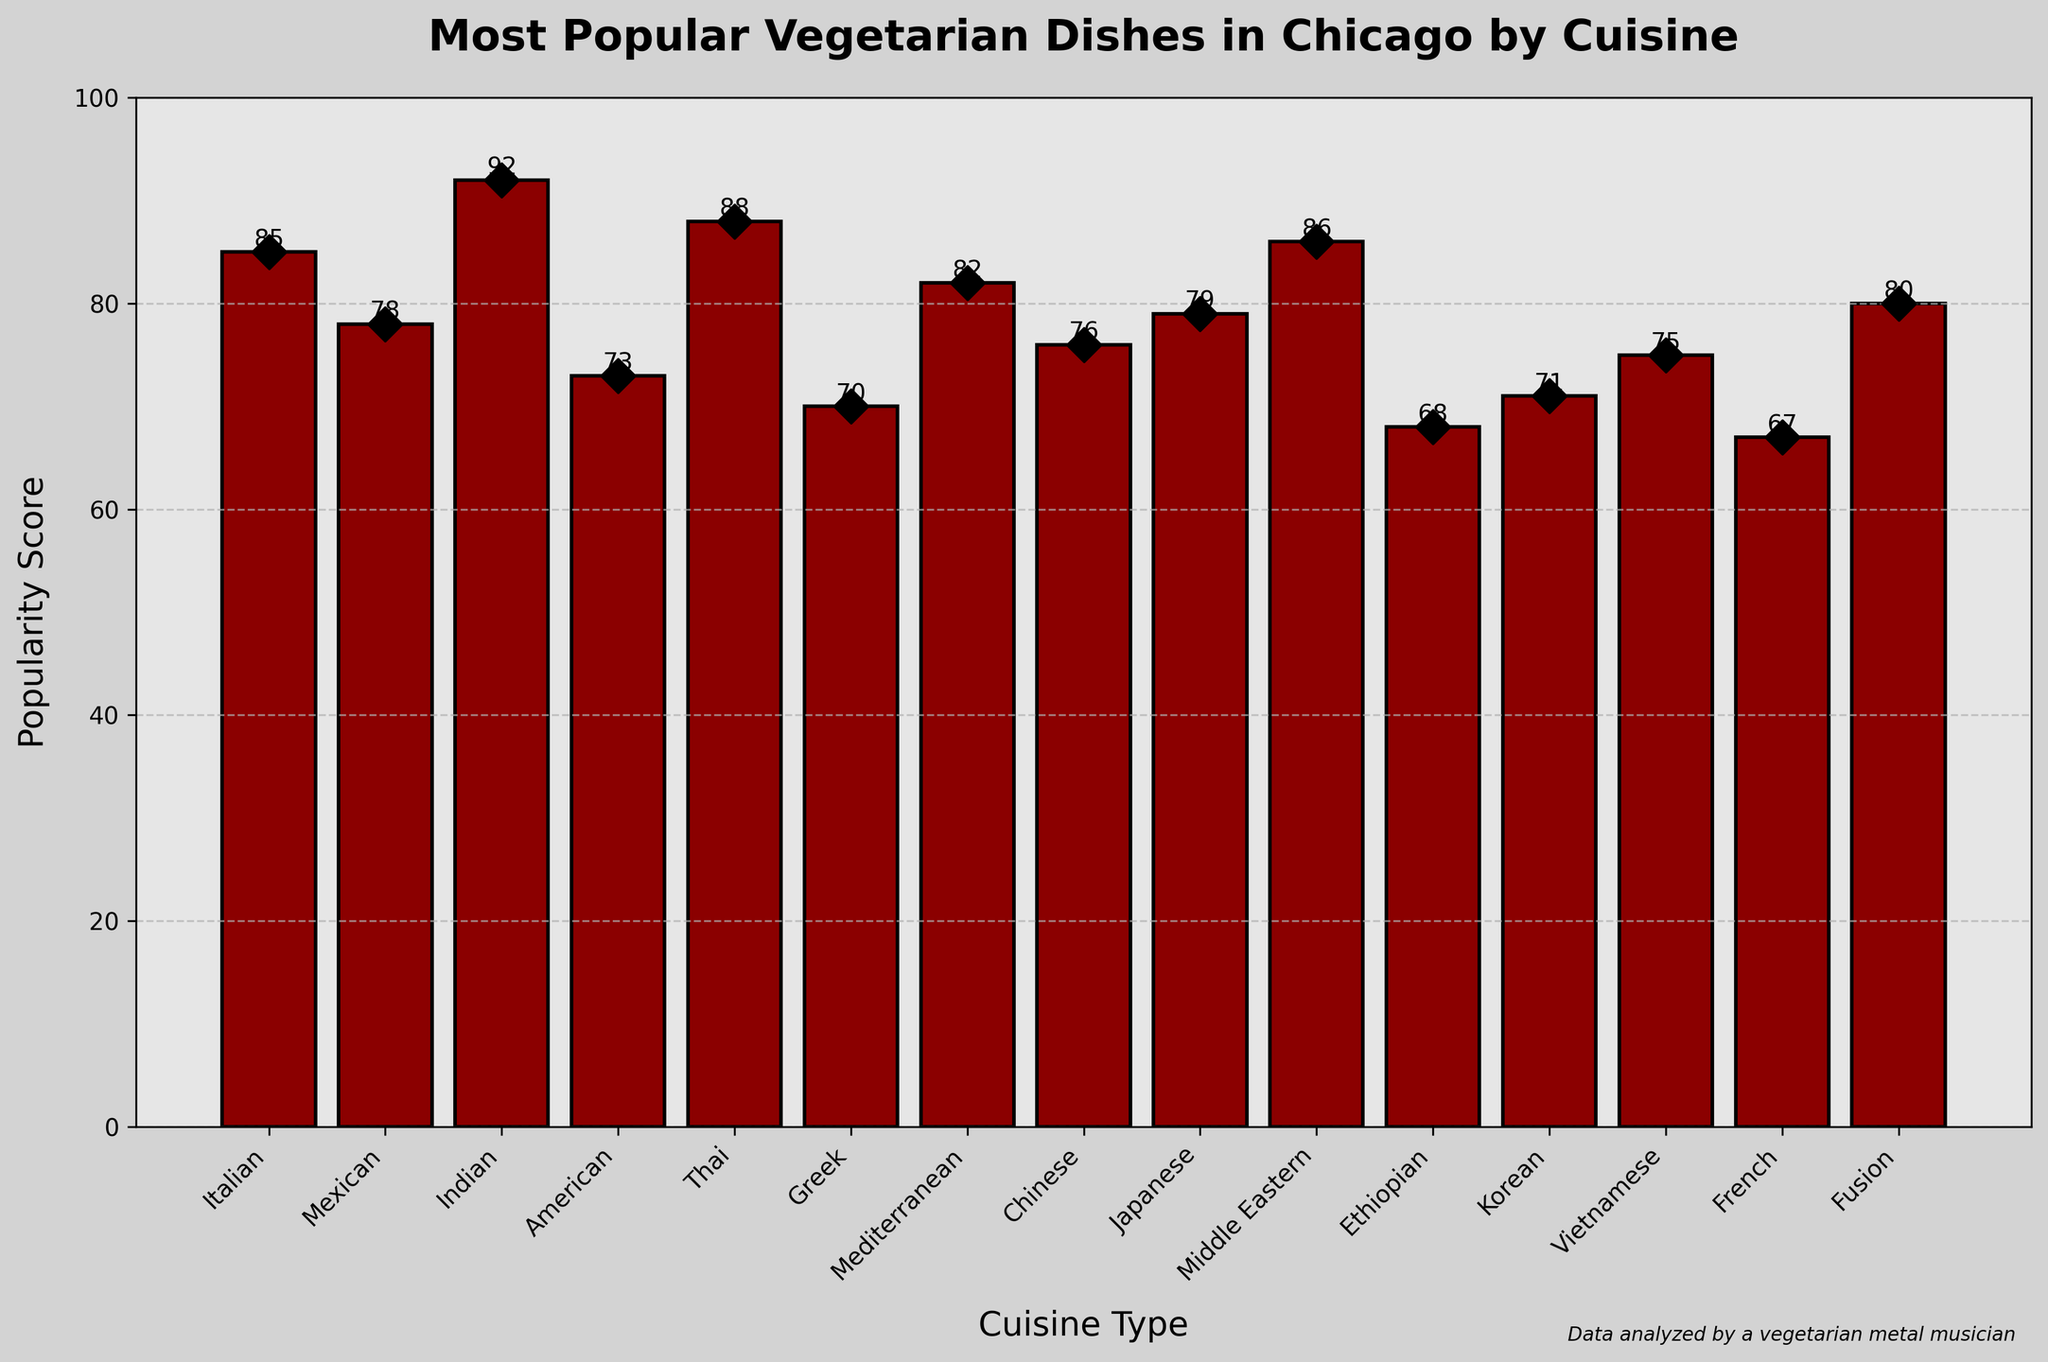Which cuisine has the highest popularity score? The cuisine with the tallest bar represents the highest popularity score. Indian cuisine has the tallest bar.
Answer: Indian Which cuisine has the lowest popularity score? The cuisine with the shortest bar represents the lowest popularity score. French cuisine has the shortest bar.
Answer: French Compare the popularity scores of Thai and Greek cuisines. Which is higher? Look at the heights of the bars for Thai and Greek cuisines. The Thai cuisine bar is taller than the Greek cuisine bar.
Answer: Thai What is the average popularity score of all the cuisines combined? Sum all the popularity scores and divide by the number of cuisines. (85 + 78 + 92 + 73 + 88 + 70 + 82 + 76 + 79 + 86 + 68 + 71 + 75 + 67 + 80) = 1120, there are 15 cuisines, so the average is 1120 / 15 = 74.67
Answer: 74.67 How much higher is the popularity score of Italian cuisine compared to American cuisine? Subtract the popularity score of American cuisine from Italian cuisine. 85 (Italian) - 73 (American) = 12
Answer: 12 Is Middle Eastern cuisine more popular than Mediterranean cuisine based on their scores? Compare the heights of the bars for Middle Eastern and Mediterranean cuisines. The Middle Eastern cuisine bar is slightly taller than the Mediterranean cuisine bar.
Answer: Yes Arrange the cuisine types in descending order of popularity scores. List the cuisine types based on the height of their bars from tallest to shortest: Indian, Thai, Middle Eastern, Italian, Mediterranean, Fusion, Japanese, Mexican, Chinese, Vietnamese, American, Korean, Greek, Ethiopian, French
Answer: Indian, Thai, Middle Eastern, Italian, Mediterranean, Fusion, Japanese, Mexican, Chinese, Vietnamese, American, Korean, Greek, Ethiopian, French What is the median popularity score among the cuisines? Order the popularity scores and find the middle value. Ordered scores: (67, 68, 70, 71, 73, 75, 76, 78, 79, 80, 82, 85, 86, 88, 92). The median is the middle score: 78.
Answer: 78 Which cuisine has a popularity score closest to 80? Look for the bar with the height closest to 80. Fusion cuisine has a score of exactly 80.
Answer: Fusion 